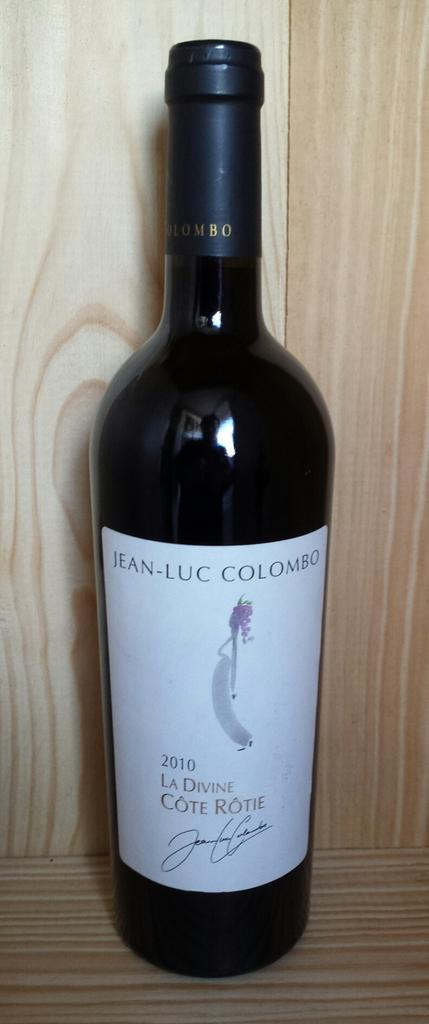<image>
Give a short and clear explanation of the subsequent image. A dark colored glass bottle of Jean-Luc Colombo La Divine Cote Rotie from 2010 with a white label. 